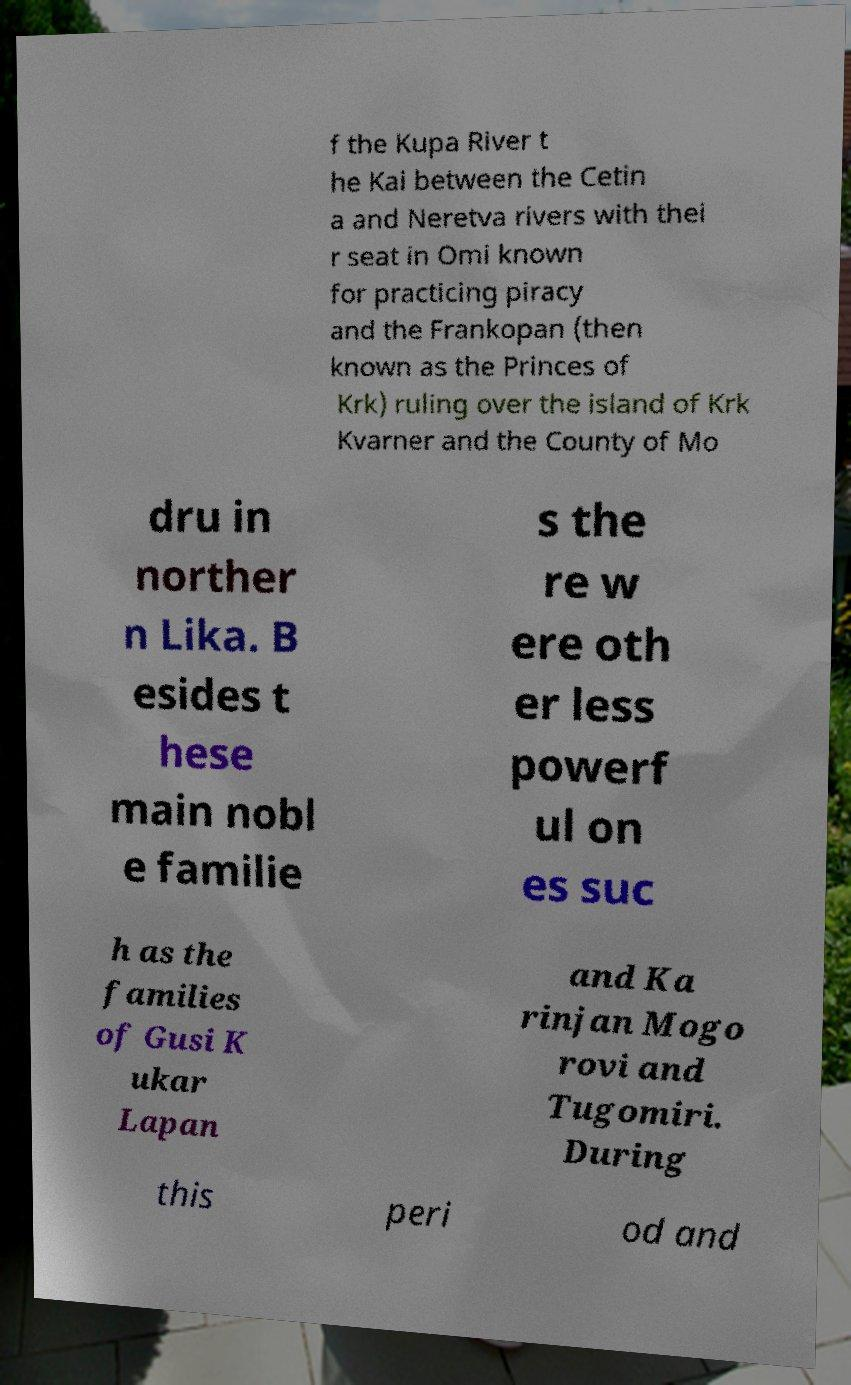Please identify and transcribe the text found in this image. f the Kupa River t he Kai between the Cetin a and Neretva rivers with thei r seat in Omi known for practicing piracy and the Frankopan (then known as the Princes of Krk) ruling over the island of Krk Kvarner and the County of Mo dru in norther n Lika. B esides t hese main nobl e familie s the re w ere oth er less powerf ul on es suc h as the families of Gusi K ukar Lapan and Ka rinjan Mogo rovi and Tugomiri. During this peri od and 